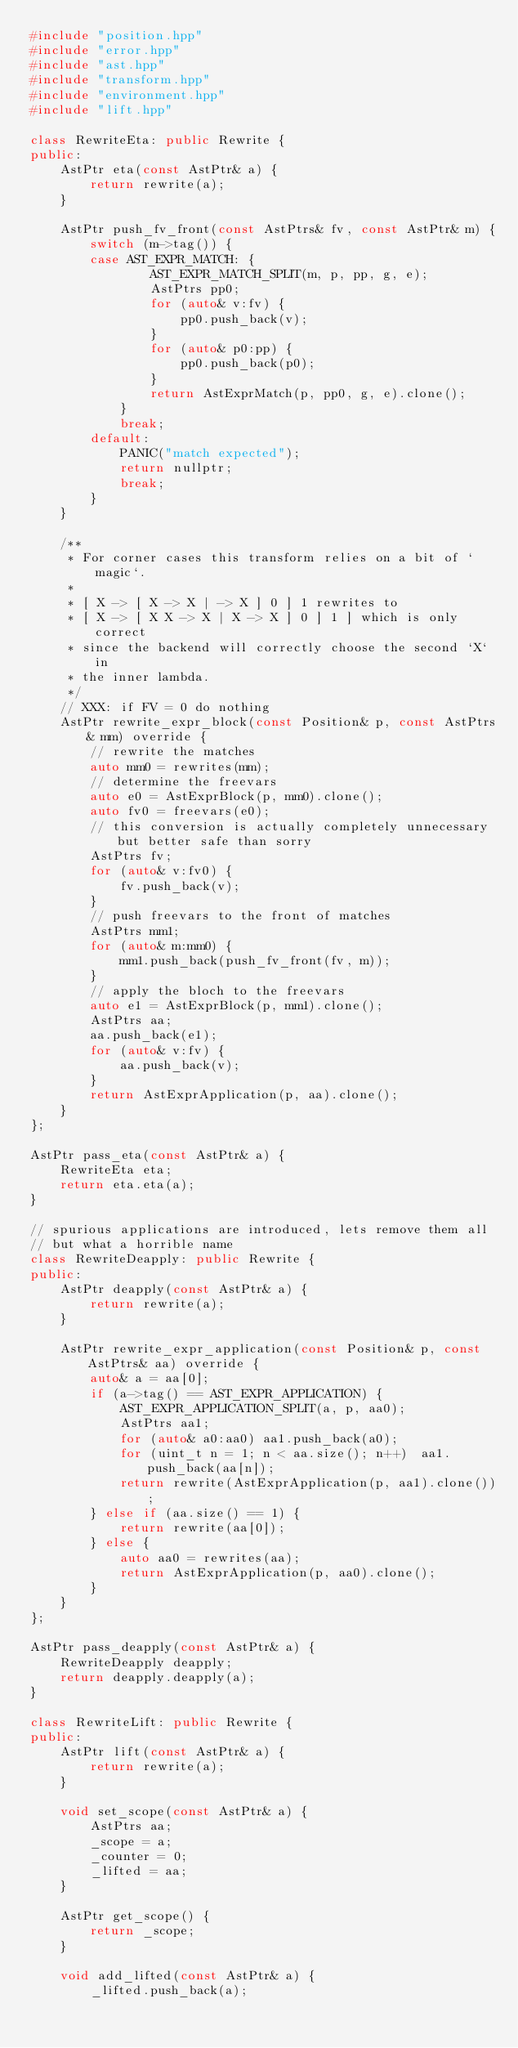<code> <loc_0><loc_0><loc_500><loc_500><_C++_>#include "position.hpp"
#include "error.hpp"
#include "ast.hpp"
#include "transform.hpp"
#include "environment.hpp"
#include "lift.hpp"

class RewriteEta: public Rewrite {
public:
    AstPtr eta(const AstPtr& a) {
        return rewrite(a);
    }

    AstPtr push_fv_front(const AstPtrs& fv, const AstPtr& m) {
        switch (m->tag()) {
        case AST_EXPR_MATCH: {
                AST_EXPR_MATCH_SPLIT(m, p, pp, g, e);
                AstPtrs pp0;
                for (auto& v:fv) {
                    pp0.push_back(v);
                }
                for (auto& p0:pp) {
                    pp0.push_back(p0);
                }
                return AstExprMatch(p, pp0, g, e).clone();
            }
            break;
        default:
            PANIC("match expected");
            return nullptr;
            break;
        }
    }

    /**
     * For corner cases this transform relies on a bit of `magic`.
     *
     * [ X -> [ X -> X | -> X ] 0 ] 1 rewrites to
     * [ X -> [ X X -> X | X -> X ] 0 ] 1 ] which is only correct
     * since the backend will correctly choose the second `X` in 
     * the inner lambda.
     */
    // XXX: if FV = 0 do nothing
    AstPtr rewrite_expr_block(const Position& p, const AstPtrs& mm) override {
        // rewrite the matches
        auto mm0 = rewrites(mm);
        // determine the freevars
        auto e0 = AstExprBlock(p, mm0).clone();
        auto fv0 = freevars(e0);
        // this conversion is actually completely unnecessary but better safe than sorry
        AstPtrs fv;
        for (auto& v:fv0) {
            fv.push_back(v);
        }
        // push freevars to the front of matches
        AstPtrs mm1;
        for (auto& m:mm0) {
            mm1.push_back(push_fv_front(fv, m));
        }
        // apply the bloch to the freevars
        auto e1 = AstExprBlock(p, mm1).clone();
        AstPtrs aa;
        aa.push_back(e1);
        for (auto& v:fv) {
            aa.push_back(v);
        }
        return AstExprApplication(p, aa).clone();
    }
};

AstPtr pass_eta(const AstPtr& a) {
    RewriteEta eta;
    return eta.eta(a);
}

// spurious applications are introduced, lets remove them all
// but what a horrible name
class RewriteDeapply: public Rewrite {
public:
    AstPtr deapply(const AstPtr& a) {
        return rewrite(a);
    }

    AstPtr rewrite_expr_application(const Position& p, const AstPtrs& aa) override {
        auto& a = aa[0];
        if (a->tag() == AST_EXPR_APPLICATION) {
            AST_EXPR_APPLICATION_SPLIT(a, p, aa0);
            AstPtrs aa1;
            for (auto& a0:aa0) aa1.push_back(a0);
            for (uint_t n = 1; n < aa.size(); n++)  aa1.push_back(aa[n]);
            return rewrite(AstExprApplication(p, aa1).clone());
        } else if (aa.size() == 1) {
            return rewrite(aa[0]);
        } else {
            auto aa0 = rewrites(aa);
            return AstExprApplication(p, aa0).clone();
        }
    }
};

AstPtr pass_deapply(const AstPtr& a) {
    RewriteDeapply deapply;
    return deapply.deapply(a);
}

class RewriteLift: public Rewrite {
public:
    AstPtr lift(const AstPtr& a) {
        return rewrite(a);
    }

    void set_scope(const AstPtr& a) {
        AstPtrs aa;
        _scope = a;
        _counter = 0;
        _lifted = aa;
    }

    AstPtr get_scope() {
        return _scope;
    }

    void add_lifted(const AstPtr& a) {
        _lifted.push_back(a);</code> 